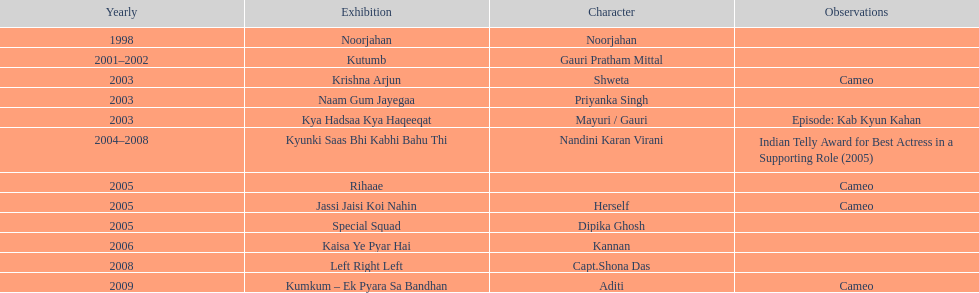Help me parse the entirety of this table. {'header': ['Yearly', 'Exhibition', 'Character', 'Observations'], 'rows': [['1998', 'Noorjahan', 'Noorjahan', ''], ['2001–2002', 'Kutumb', 'Gauri Pratham Mittal', ''], ['2003', 'Krishna Arjun', 'Shweta', 'Cameo'], ['2003', 'Naam Gum Jayegaa', 'Priyanka Singh', ''], ['2003', 'Kya Hadsaa Kya Haqeeqat', 'Mayuri / Gauri', 'Episode: Kab Kyun Kahan'], ['2004–2008', 'Kyunki Saas Bhi Kabhi Bahu Thi', 'Nandini Karan Virani', 'Indian Telly Award for Best Actress in a Supporting Role (2005)'], ['2005', 'Rihaae', '', 'Cameo'], ['2005', 'Jassi Jaisi Koi Nahin', 'Herself', 'Cameo'], ['2005', 'Special Squad', 'Dipika Ghosh', ''], ['2006', 'Kaisa Ye Pyar Hai', 'Kannan', ''], ['2008', 'Left Right Left', 'Capt.Shona Das', ''], ['2009', 'Kumkum – Ek Pyara Sa Bandhan', 'Aditi', 'Cameo']]} The show above left right left Kaisa Ye Pyar Hai. 